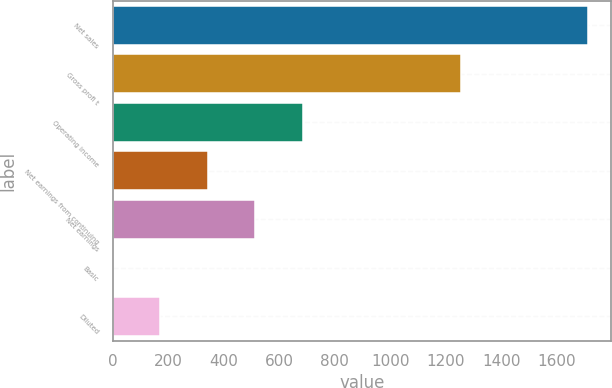Convert chart to OTSL. <chart><loc_0><loc_0><loc_500><loc_500><bar_chart><fcel>Net sales<fcel>Gross profi t<fcel>Operating income<fcel>Net earnings from continuing<fcel>Net earnings<fcel>Basic<fcel>Diluted<nl><fcel>1710.1<fcel>1254.3<fcel>684.16<fcel>342.18<fcel>513.17<fcel>0.2<fcel>171.19<nl></chart> 